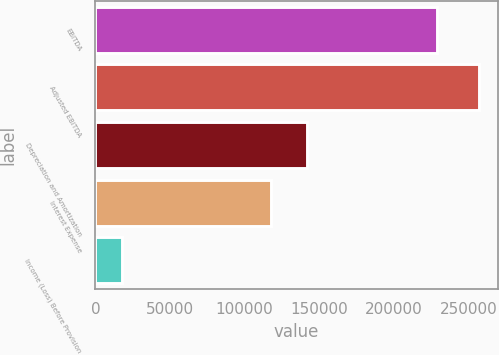<chart> <loc_0><loc_0><loc_500><loc_500><bar_chart><fcel>EBITDA<fcel>Adjusted EBITDA<fcel>Depreciation and Amortization<fcel>Interest Expense<fcel>Income (Loss) Before Provision<nl><fcel>228977<fcel>257041<fcel>141876<fcel>117975<fcel>18032<nl></chart> 